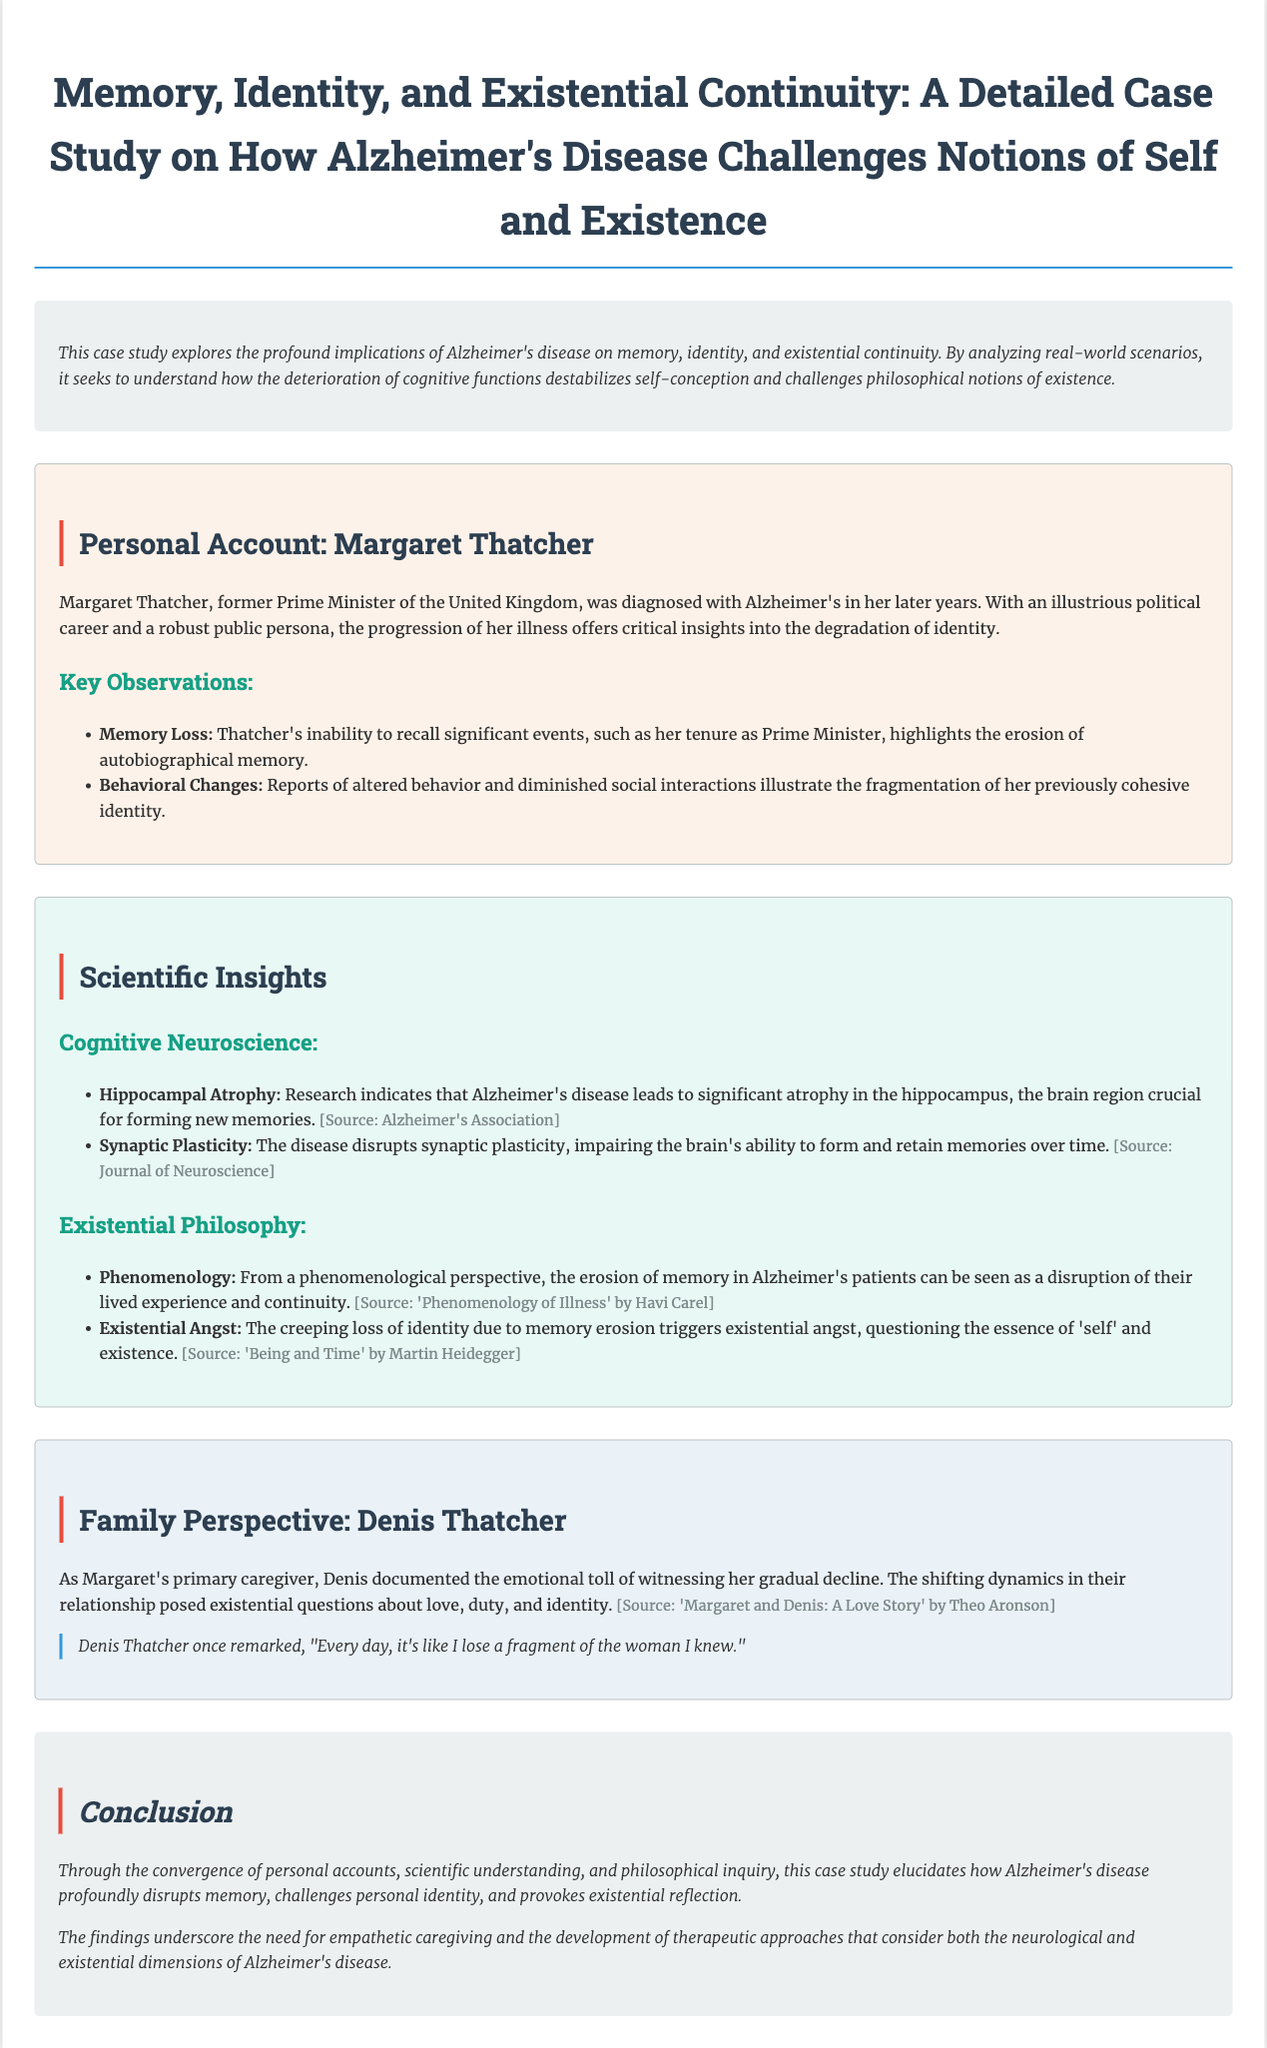What was Margaret Thatcher diagnosed with? The document states that Margaret Thatcher was diagnosed with Alzheimer's disease in her later years.
Answer: Alzheimer's disease What significant brain region is affected by Alzheimer's? It indicates that Alzheimer's leads to significant atrophy in the hippocampus, which is crucial for forming new memories.
Answer: Hippocampus What did Denis Thatcher document? The document mentions that Denis documented the emotional toll of witnessing Margaret's gradual decline.
Answer: Emotional toll Which philosophical perspective is mentioned regarding memory erosion? The case study highlights phenomenology as a relevant philosophical perspective regarding the disruption of lived experience.
Answer: Phenomenology What does the erosion of identity trigger according to the document? It states that the creeping loss of identity due to memory erosion triggers existential angst, questioning the essence of 'self' and existence.
Answer: Existential angst 